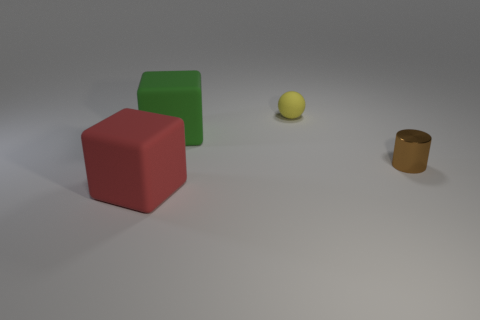Add 3 big red matte things. How many objects exist? 7 Subtract all balls. How many objects are left? 3 Subtract all rubber blocks. Subtract all spheres. How many objects are left? 1 Add 1 tiny brown cylinders. How many tiny brown cylinders are left? 2 Add 3 green matte objects. How many green matte objects exist? 4 Subtract 0 purple balls. How many objects are left? 4 